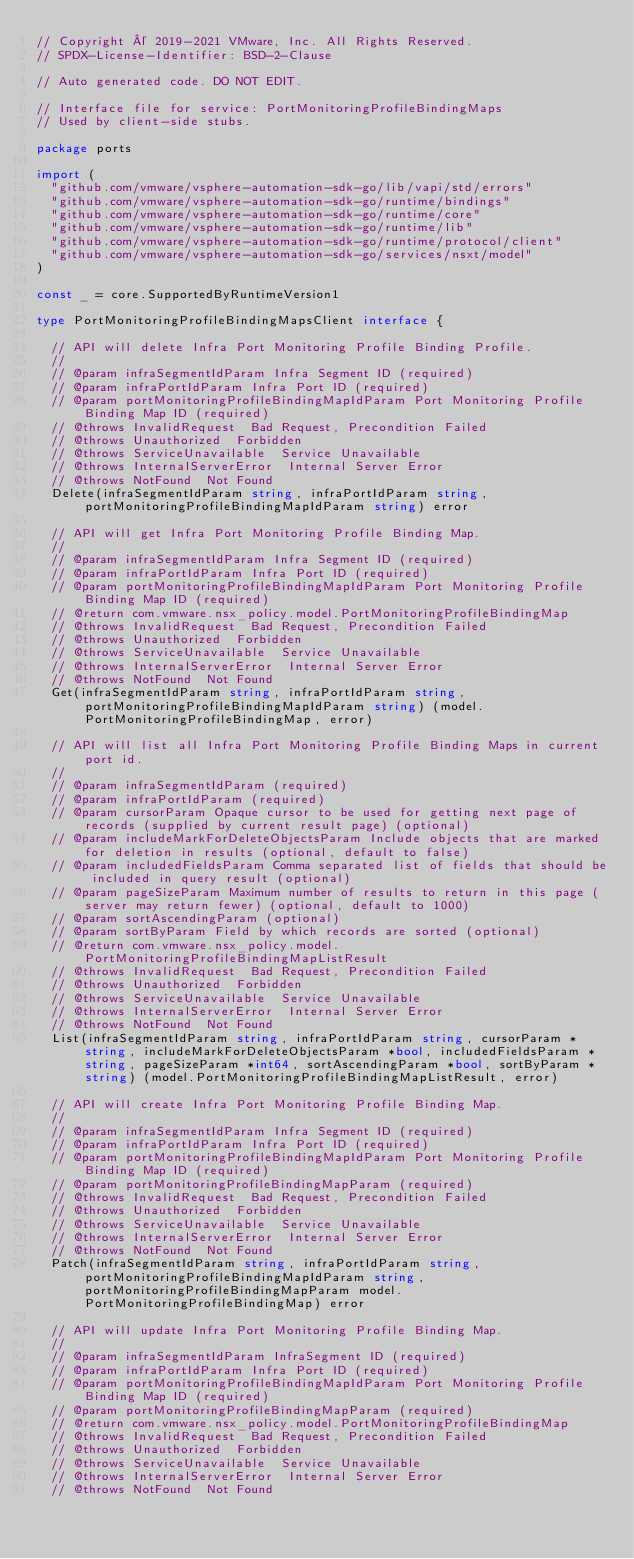<code> <loc_0><loc_0><loc_500><loc_500><_Go_>// Copyright © 2019-2021 VMware, Inc. All Rights Reserved.
// SPDX-License-Identifier: BSD-2-Clause

// Auto generated code. DO NOT EDIT.

// Interface file for service: PortMonitoringProfileBindingMaps
// Used by client-side stubs.

package ports

import (
	"github.com/vmware/vsphere-automation-sdk-go/lib/vapi/std/errors"
	"github.com/vmware/vsphere-automation-sdk-go/runtime/bindings"
	"github.com/vmware/vsphere-automation-sdk-go/runtime/core"
	"github.com/vmware/vsphere-automation-sdk-go/runtime/lib"
	"github.com/vmware/vsphere-automation-sdk-go/runtime/protocol/client"
	"github.com/vmware/vsphere-automation-sdk-go/services/nsxt/model"
)

const _ = core.SupportedByRuntimeVersion1

type PortMonitoringProfileBindingMapsClient interface {

	// API will delete Infra Port Monitoring Profile Binding Profile.
	//
	// @param infraSegmentIdParam Infra Segment ID (required)
	// @param infraPortIdParam Infra Port ID (required)
	// @param portMonitoringProfileBindingMapIdParam Port Monitoring Profile Binding Map ID (required)
	// @throws InvalidRequest  Bad Request, Precondition Failed
	// @throws Unauthorized  Forbidden
	// @throws ServiceUnavailable  Service Unavailable
	// @throws InternalServerError  Internal Server Error
	// @throws NotFound  Not Found
	Delete(infraSegmentIdParam string, infraPortIdParam string, portMonitoringProfileBindingMapIdParam string) error

	// API will get Infra Port Monitoring Profile Binding Map.
	//
	// @param infraSegmentIdParam Infra Segment ID (required)
	// @param infraPortIdParam Infra Port ID (required)
	// @param portMonitoringProfileBindingMapIdParam Port Monitoring Profile Binding Map ID (required)
	// @return com.vmware.nsx_policy.model.PortMonitoringProfileBindingMap
	// @throws InvalidRequest  Bad Request, Precondition Failed
	// @throws Unauthorized  Forbidden
	// @throws ServiceUnavailable  Service Unavailable
	// @throws InternalServerError  Internal Server Error
	// @throws NotFound  Not Found
	Get(infraSegmentIdParam string, infraPortIdParam string, portMonitoringProfileBindingMapIdParam string) (model.PortMonitoringProfileBindingMap, error)

	// API will list all Infra Port Monitoring Profile Binding Maps in current port id.
	//
	// @param infraSegmentIdParam (required)
	// @param infraPortIdParam (required)
	// @param cursorParam Opaque cursor to be used for getting next page of records (supplied by current result page) (optional)
	// @param includeMarkForDeleteObjectsParam Include objects that are marked for deletion in results (optional, default to false)
	// @param includedFieldsParam Comma separated list of fields that should be included in query result (optional)
	// @param pageSizeParam Maximum number of results to return in this page (server may return fewer) (optional, default to 1000)
	// @param sortAscendingParam (optional)
	// @param sortByParam Field by which records are sorted (optional)
	// @return com.vmware.nsx_policy.model.PortMonitoringProfileBindingMapListResult
	// @throws InvalidRequest  Bad Request, Precondition Failed
	// @throws Unauthorized  Forbidden
	// @throws ServiceUnavailable  Service Unavailable
	// @throws InternalServerError  Internal Server Error
	// @throws NotFound  Not Found
	List(infraSegmentIdParam string, infraPortIdParam string, cursorParam *string, includeMarkForDeleteObjectsParam *bool, includedFieldsParam *string, pageSizeParam *int64, sortAscendingParam *bool, sortByParam *string) (model.PortMonitoringProfileBindingMapListResult, error)

	// API will create Infra Port Monitoring Profile Binding Map.
	//
	// @param infraSegmentIdParam Infra Segment ID (required)
	// @param infraPortIdParam Infra Port ID (required)
	// @param portMonitoringProfileBindingMapIdParam Port Monitoring Profile Binding Map ID (required)
	// @param portMonitoringProfileBindingMapParam (required)
	// @throws InvalidRequest  Bad Request, Precondition Failed
	// @throws Unauthorized  Forbidden
	// @throws ServiceUnavailable  Service Unavailable
	// @throws InternalServerError  Internal Server Error
	// @throws NotFound  Not Found
	Patch(infraSegmentIdParam string, infraPortIdParam string, portMonitoringProfileBindingMapIdParam string, portMonitoringProfileBindingMapParam model.PortMonitoringProfileBindingMap) error

	// API will update Infra Port Monitoring Profile Binding Map.
	//
	// @param infraSegmentIdParam InfraSegment ID (required)
	// @param infraPortIdParam Infra Port ID (required)
	// @param portMonitoringProfileBindingMapIdParam Port Monitoring Profile Binding Map ID (required)
	// @param portMonitoringProfileBindingMapParam (required)
	// @return com.vmware.nsx_policy.model.PortMonitoringProfileBindingMap
	// @throws InvalidRequest  Bad Request, Precondition Failed
	// @throws Unauthorized  Forbidden
	// @throws ServiceUnavailable  Service Unavailable
	// @throws InternalServerError  Internal Server Error
	// @throws NotFound  Not Found</code> 